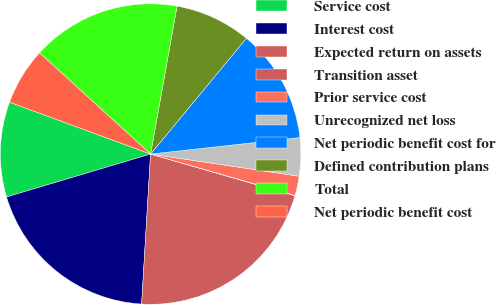Convert chart. <chart><loc_0><loc_0><loc_500><loc_500><pie_chart><fcel>Service cost<fcel>Interest cost<fcel>Expected return on assets<fcel>Transition asset<fcel>Prior service cost<fcel>Unrecognized net loss<fcel>Net periodic benefit cost for<fcel>Defined contribution plans<fcel>Total<fcel>Net periodic benefit cost<nl><fcel>10.22%<fcel>19.44%<fcel>21.47%<fcel>0.04%<fcel>2.08%<fcel>4.11%<fcel>12.25%<fcel>8.18%<fcel>16.06%<fcel>6.15%<nl></chart> 